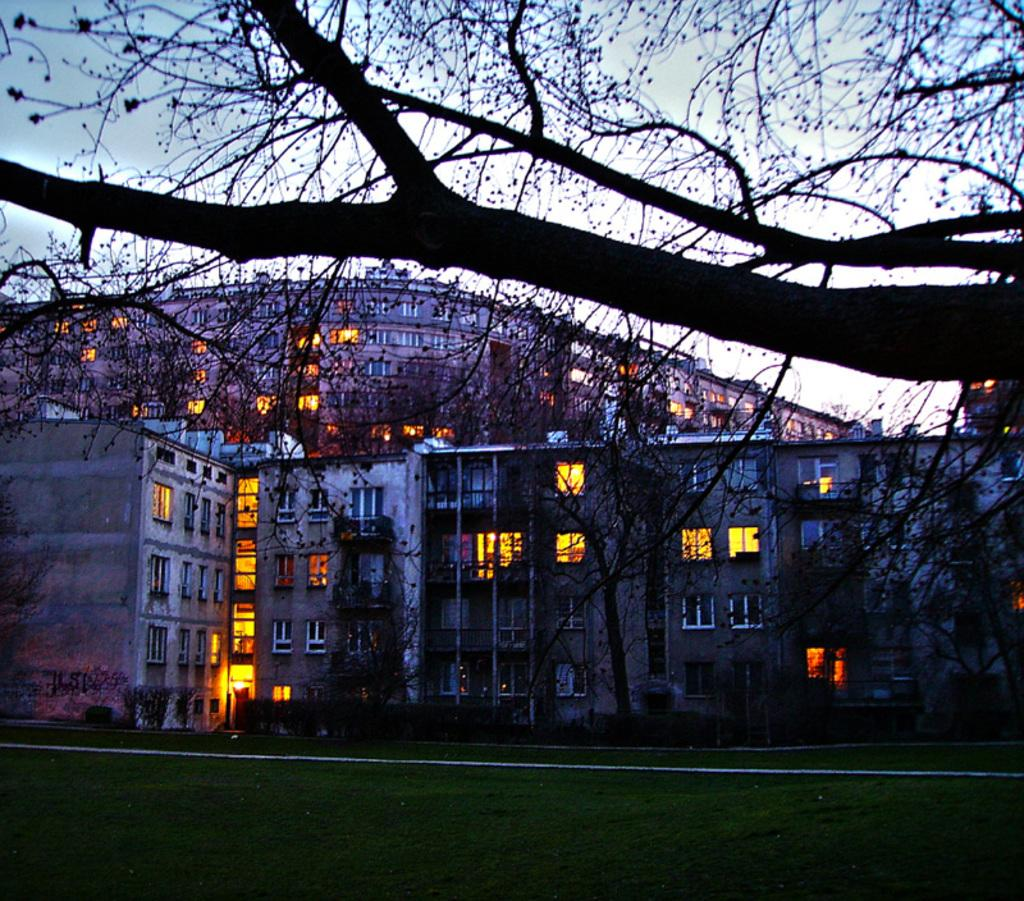What type of vegetation can be seen in the image? There are trees, grass, and plants in the image. What type of structures are present in the image? There are buildings in the image. What is visible in the background of the image? The sky is visible in the background of the image. Where is the worm located in the image? There is no worm present in the image. What type of door can be seen in the image? There is no door present in the image. 